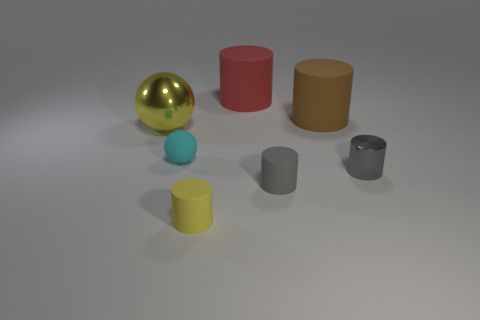There is a red object that is made of the same material as the big brown thing; what size is it?
Offer a terse response. Large. Are there fewer tiny things than large cylinders?
Make the answer very short. No. There is a cylinder that is the same size as the brown thing; what material is it?
Keep it short and to the point. Rubber. Are there more small gray objects than matte objects?
Offer a very short reply. No. How many other things are the same color as the large metal sphere?
Your answer should be very brief. 1. How many matte cylinders are both in front of the yellow metallic object and behind the shiny cylinder?
Provide a succinct answer. 0. Is the number of small gray objects that are right of the big brown cylinder greater than the number of gray metallic things to the left of the small gray matte cylinder?
Your answer should be very brief. Yes. There is a large thing that is left of the large red matte object; what is its material?
Give a very brief answer. Metal. Do the yellow shiny object and the small rubber object to the left of the small yellow matte cylinder have the same shape?
Give a very brief answer. Yes. What number of red matte objects are on the right side of the metal object that is in front of the small matte object that is behind the gray matte cylinder?
Keep it short and to the point. 0. 